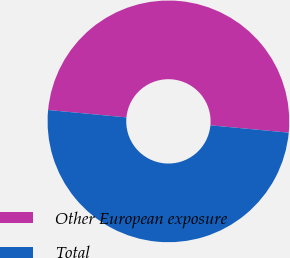Convert chart to OTSL. <chart><loc_0><loc_0><loc_500><loc_500><pie_chart><fcel>Other European exposure<fcel>Total<nl><fcel>49.99%<fcel>50.01%<nl></chart> 